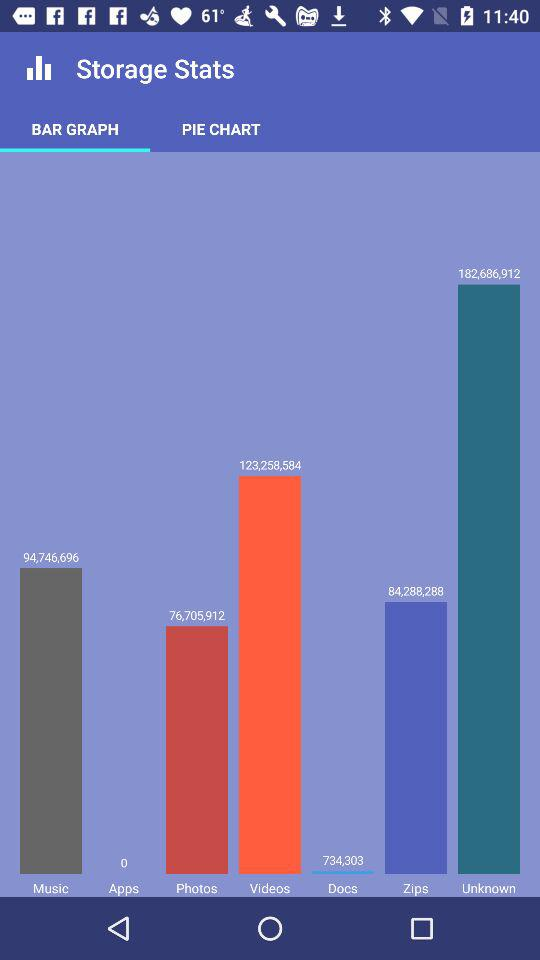What graph is being shown right now? The graph that is being shown right now is a bar graph. 